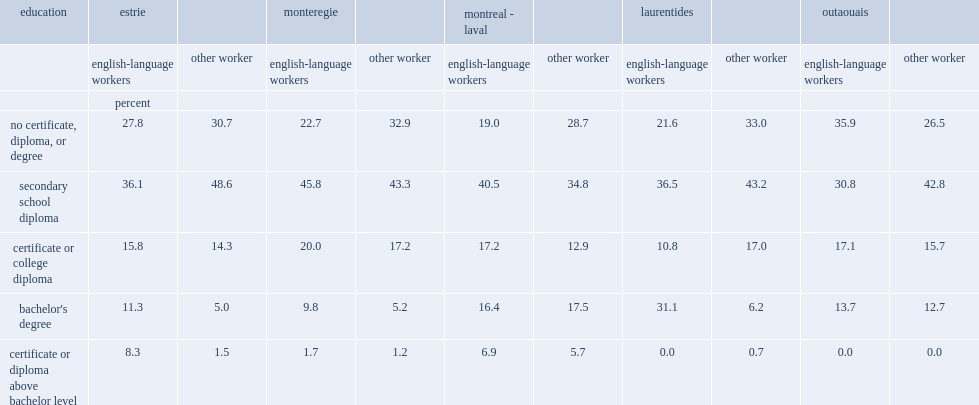Which language group of people was more likely not to have a certificate, diploma or degree in the outaouais region? english-language workers or other workers? English-language workers. Which language group of people was less likely to have a high school diploma in the outaouais region? english-language workers or other workers? English-language workers. 